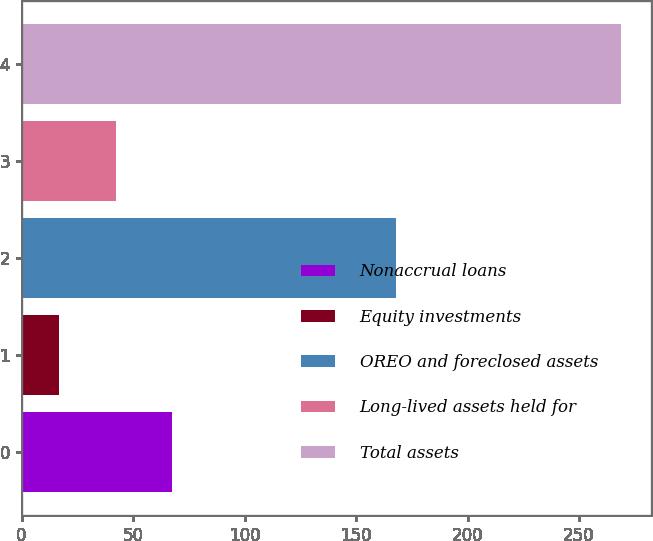<chart> <loc_0><loc_0><loc_500><loc_500><bar_chart><fcel>Nonaccrual loans<fcel>Equity investments<fcel>OREO and foreclosed assets<fcel>Long-lived assets held for<fcel>Total assets<nl><fcel>67.4<fcel>17<fcel>168<fcel>42.2<fcel>269<nl></chart> 